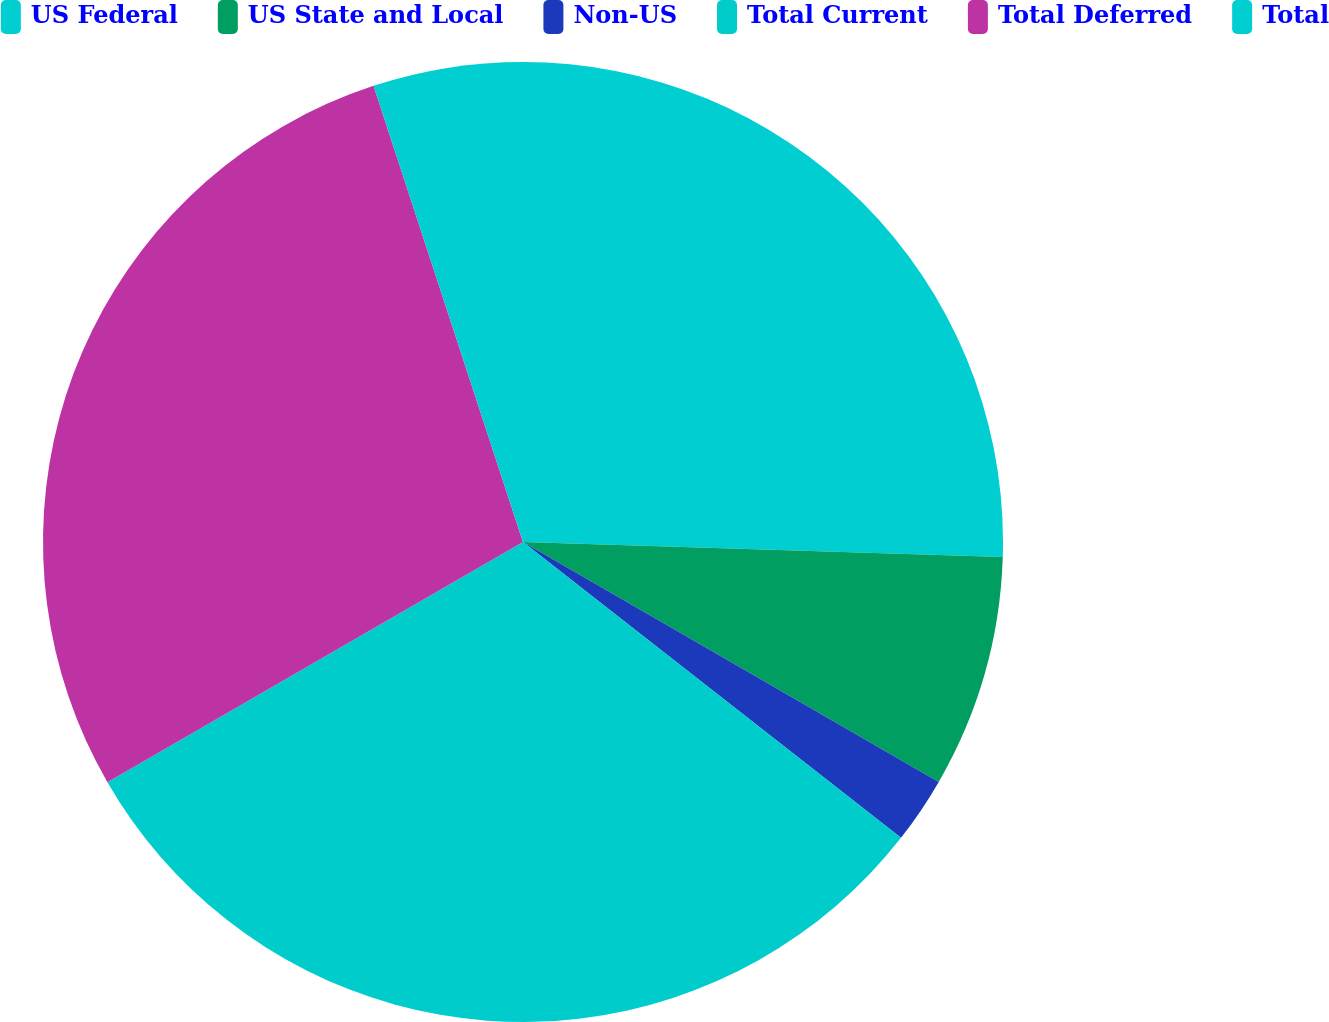<chart> <loc_0><loc_0><loc_500><loc_500><pie_chart><fcel>US Federal<fcel>US State and Local<fcel>Non-US<fcel>Total Current<fcel>Total Deferred<fcel>Total<nl><fcel>25.5%<fcel>7.83%<fcel>2.24%<fcel>31.09%<fcel>28.3%<fcel>5.04%<nl></chart> 